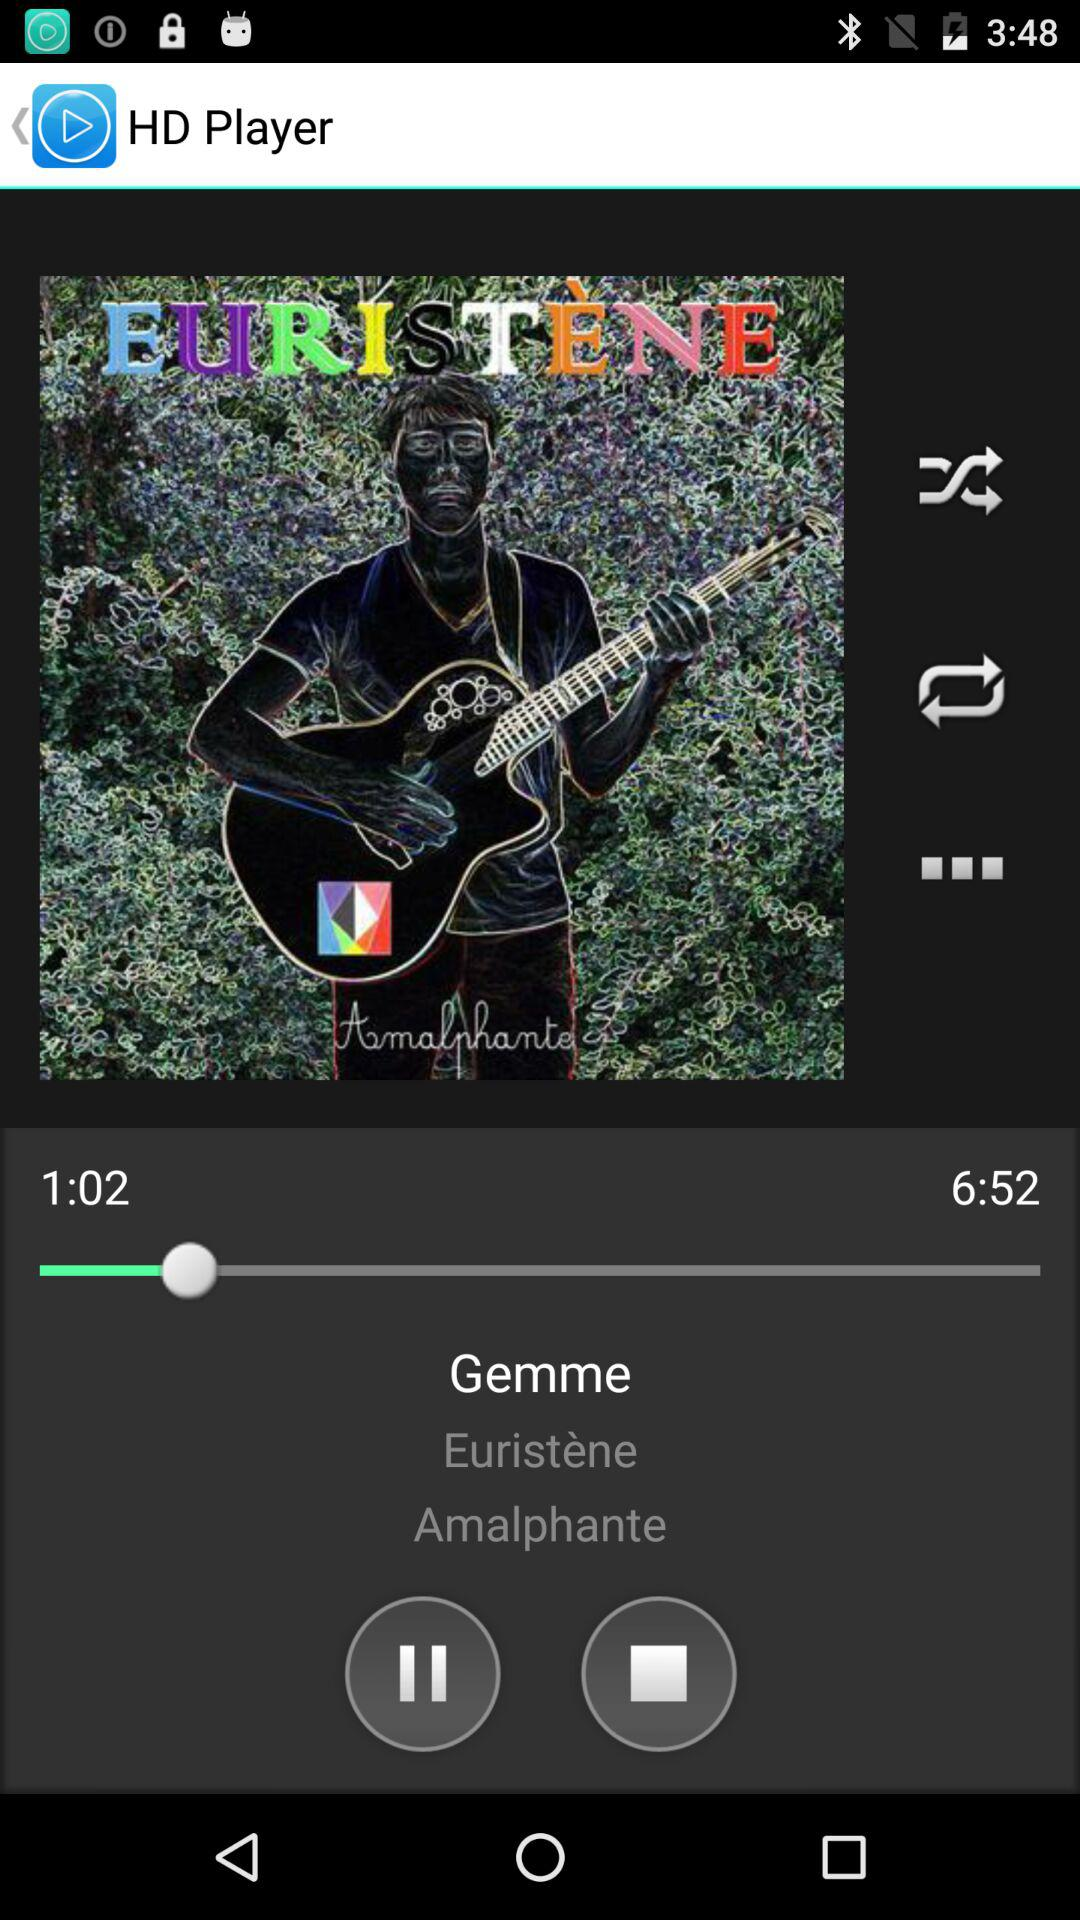What is the title of the song? The title of the song is Gemme. 